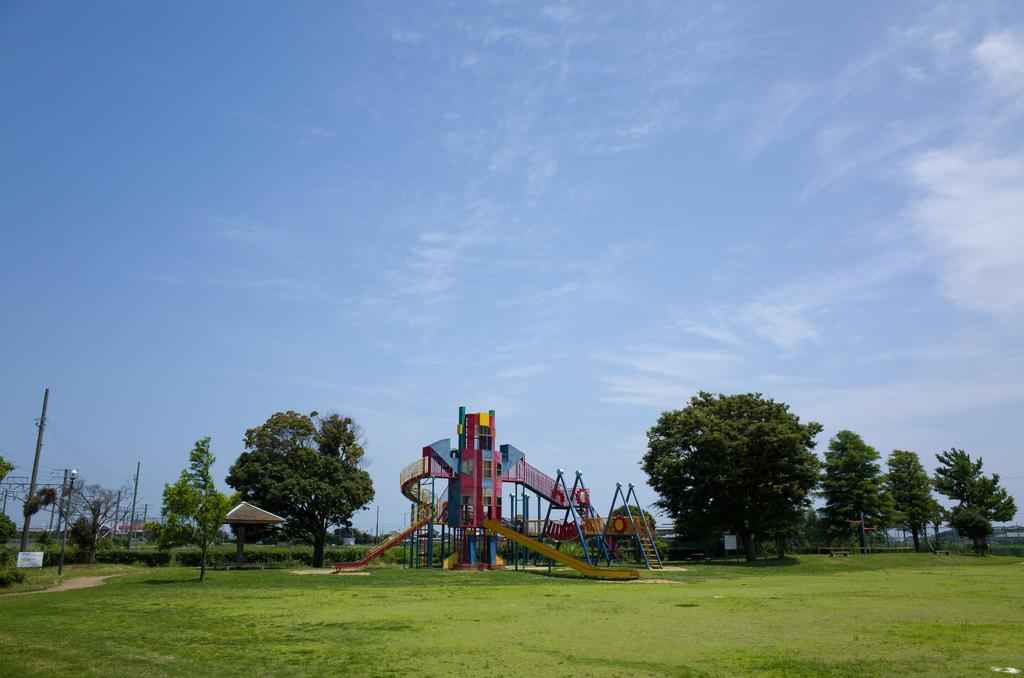What can be seen at the bottom of the image? At the bottom of the image, there are trees, electric poles, grass, cables, and land. What type of structure is present in the image? A roller coaster is present in the image. What else can be found in the image besides the roller coaster? Game items are visible in the image. What is visible at the top of the image? The sky is visible at the top of the image, and clouds are present in the sky. What color is the finger that is pointing at the roller coaster in the image? There is no finger pointing at the roller coaster in the image. What type of room is visible in the image? There is no room present in the image; it features an outdoor scene with a roller coaster and game items. 